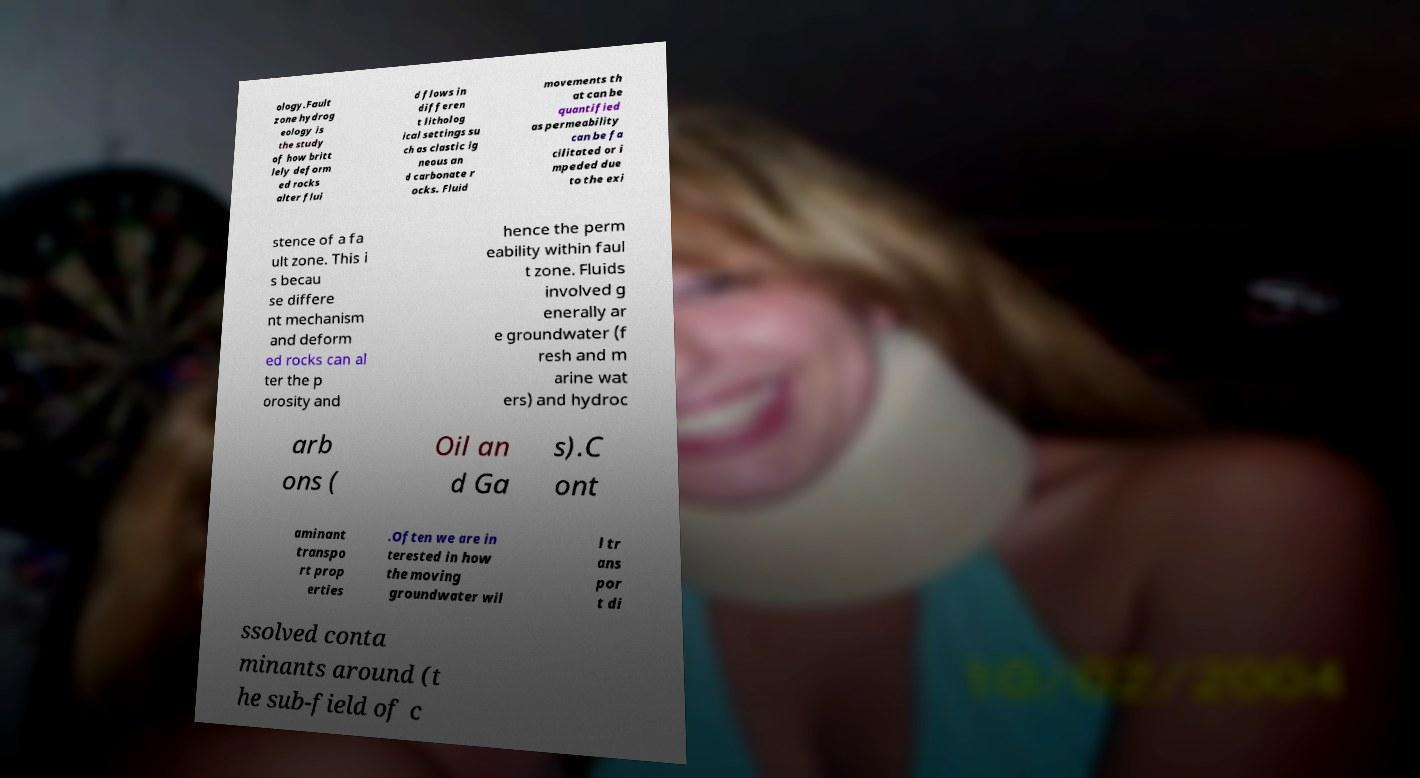Could you assist in decoding the text presented in this image and type it out clearly? ology.Fault zone hydrog eology is the study of how britt lely deform ed rocks alter flui d flows in differen t litholog ical settings su ch as clastic ig neous an d carbonate r ocks. Fluid movements th at can be quantified as permeability can be fa cilitated or i mpeded due to the exi stence of a fa ult zone. This i s becau se differe nt mechanism and deform ed rocks can al ter the p orosity and hence the perm eability within faul t zone. Fluids involved g enerally ar e groundwater (f resh and m arine wat ers) and hydroc arb ons ( Oil an d Ga s).C ont aminant transpo rt prop erties .Often we are in terested in how the moving groundwater wil l tr ans por t di ssolved conta minants around (t he sub-field of c 